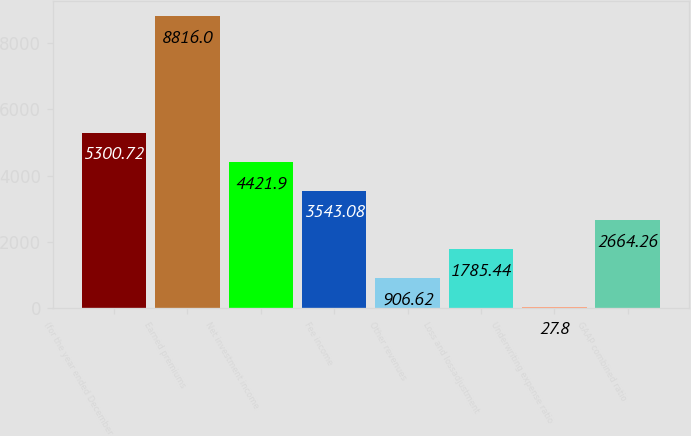Convert chart. <chart><loc_0><loc_0><loc_500><loc_500><bar_chart><fcel>(for the year ended December<fcel>Earned premiums<fcel>Net investment income<fcel>Fee income<fcel>Other revenues<fcel>Loss and lossadjustment<fcel>Underwriting expense ratio<fcel>GAAP combined ratio<nl><fcel>5300.72<fcel>8816<fcel>4421.9<fcel>3543.08<fcel>906.62<fcel>1785.44<fcel>27.8<fcel>2664.26<nl></chart> 